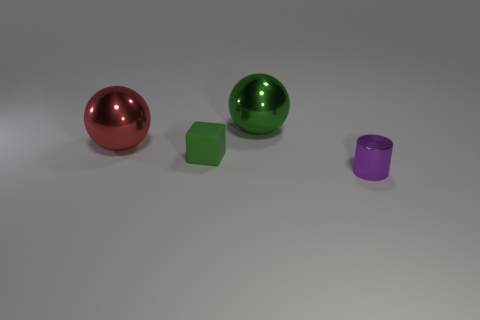Add 3 metallic cubes. How many objects exist? 7 Subtract all cylinders. How many objects are left? 3 Subtract 0 brown balls. How many objects are left? 4 Subtract all green metal spheres. Subtract all large shiny cubes. How many objects are left? 3 Add 3 green matte cubes. How many green matte cubes are left? 4 Add 1 small purple cylinders. How many small purple cylinders exist? 2 